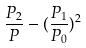Convert formula to latex. <formula><loc_0><loc_0><loc_500><loc_500>\frac { P _ { 2 } } { P } - ( \frac { P _ { 1 } } { P _ { 0 } } ) ^ { 2 }</formula> 